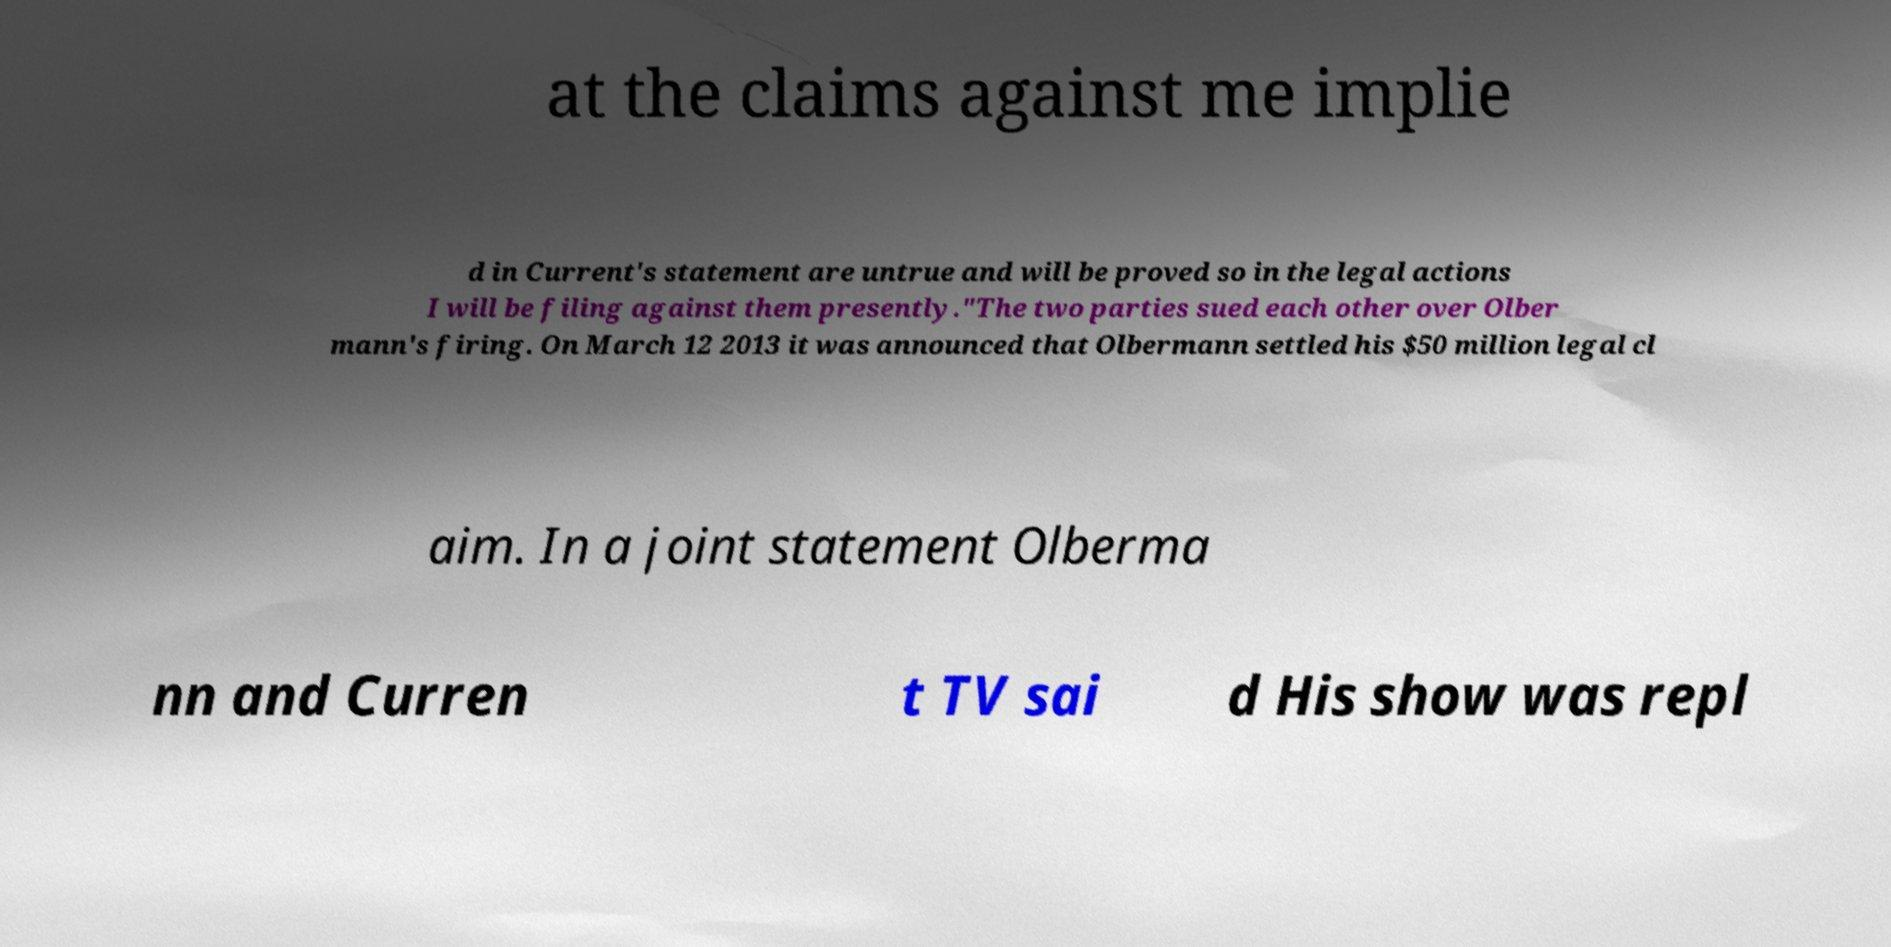Please identify and transcribe the text found in this image. at the claims against me implie d in Current's statement are untrue and will be proved so in the legal actions I will be filing against them presently."The two parties sued each other over Olber mann's firing. On March 12 2013 it was announced that Olbermann settled his $50 million legal cl aim. In a joint statement Olberma nn and Curren t TV sai d His show was repl 